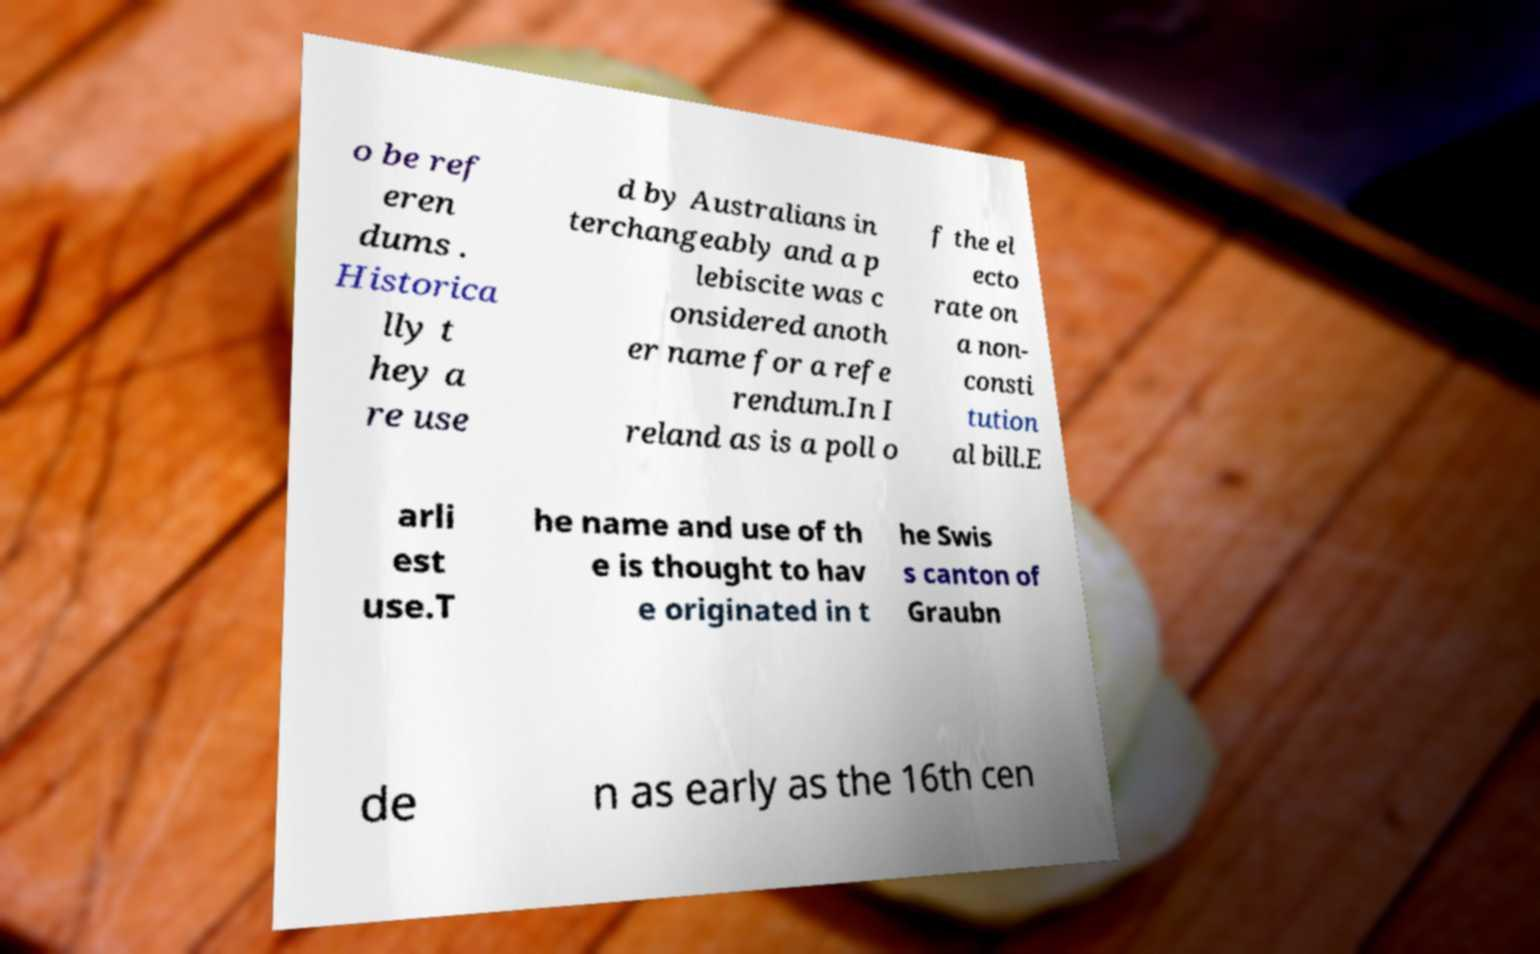Could you assist in decoding the text presented in this image and type it out clearly? o be ref eren dums . Historica lly t hey a re use d by Australians in terchangeably and a p lebiscite was c onsidered anoth er name for a refe rendum.In I reland as is a poll o f the el ecto rate on a non- consti tution al bill.E arli est use.T he name and use of th e is thought to hav e originated in t he Swis s canton of Graubn de n as early as the 16th cen 